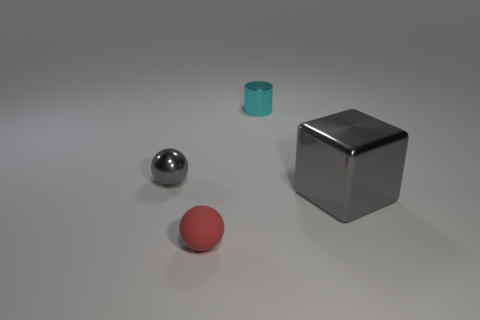Add 4 tiny red rubber spheres. How many objects exist? 8 Subtract all cylinders. How many objects are left? 3 Subtract all red balls. Subtract all cyan blocks. How many balls are left? 1 Subtract all blue cylinders. How many red balls are left? 1 Subtract all balls. Subtract all large gray blocks. How many objects are left? 1 Add 4 cyan metal things. How many cyan metal things are left? 5 Add 3 tiny red things. How many tiny red things exist? 4 Subtract 0 cyan cubes. How many objects are left? 4 